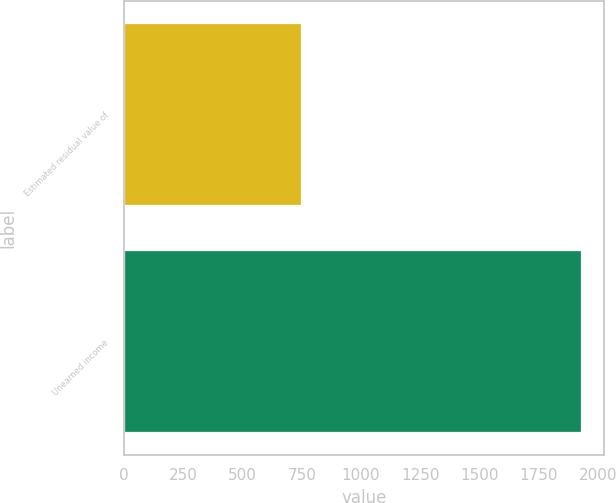Convert chart to OTSL. <chart><loc_0><loc_0><loc_500><loc_500><bar_chart><fcel>Estimated residual value of<fcel>Unearned income<nl><fcel>747<fcel>1929<nl></chart> 